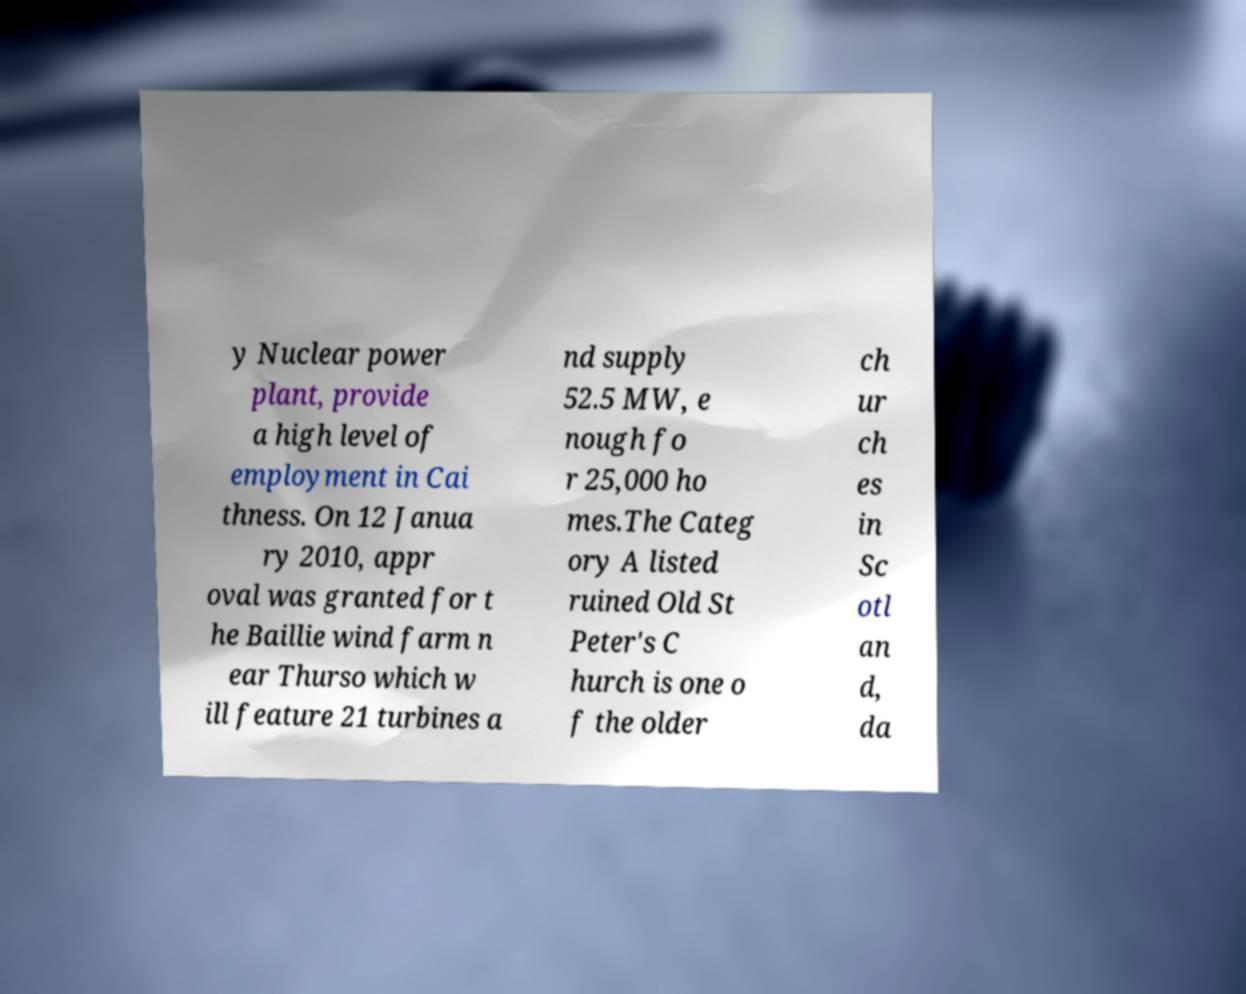There's text embedded in this image that I need extracted. Can you transcribe it verbatim? y Nuclear power plant, provide a high level of employment in Cai thness. On 12 Janua ry 2010, appr oval was granted for t he Baillie wind farm n ear Thurso which w ill feature 21 turbines a nd supply 52.5 MW, e nough fo r 25,000 ho mes.The Categ ory A listed ruined Old St Peter's C hurch is one o f the older ch ur ch es in Sc otl an d, da 